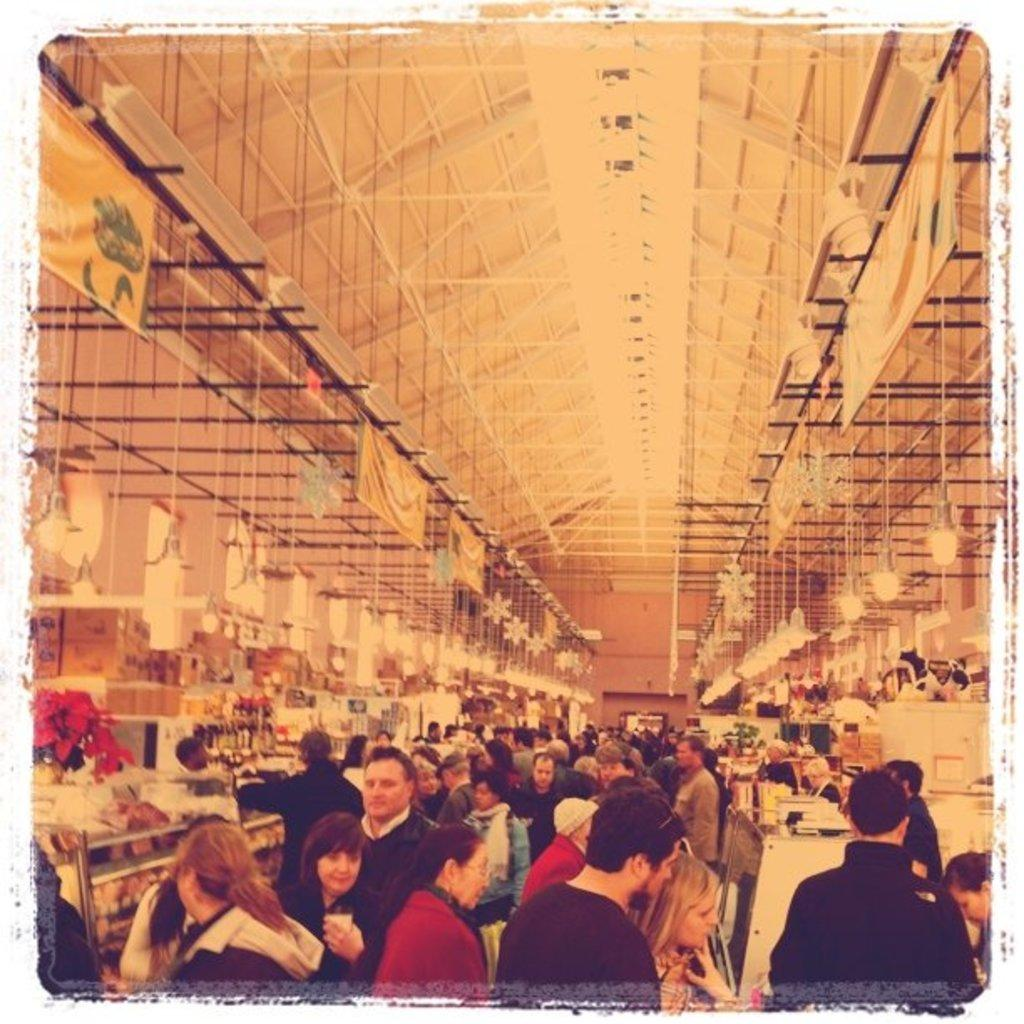Where was the image taken? The image was taken inside a hall. What can be found inside the hall? There are many shops in the hall. How crowded is the hall? There are many people inside the hall. What can be seen on the top of the hall? There are lights and banners on the top of the hall. Reasoning: Let's think step by following the given guidelines to produce the conversation. We start by identifying the location of the image, which is inside a hall. Then, we describe the main features of the hall, such as the presence of shops, people, and the lights and banners on the top. Each question is designed to elicit a specific detail about the image that is known from the provided facts. Absurd Question/Answer: How many geese are walking around the shops in the image? There are no geese present in the image; it is an indoor hall with shops and people. 